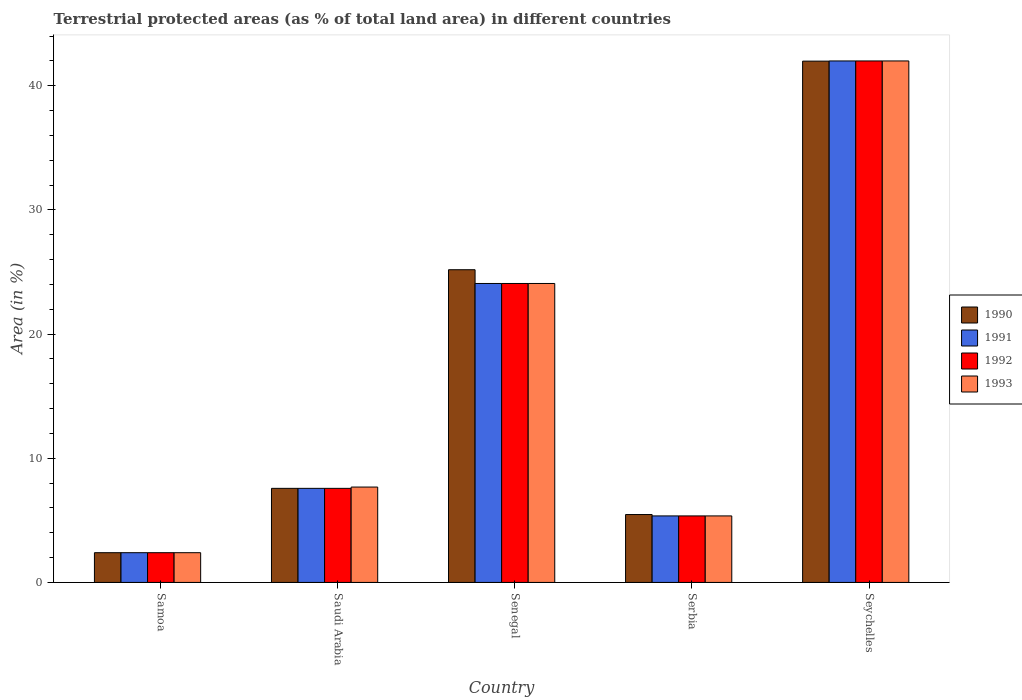How many groups of bars are there?
Your response must be concise. 5. What is the label of the 4th group of bars from the left?
Provide a short and direct response. Serbia. What is the percentage of terrestrial protected land in 1990 in Senegal?
Offer a terse response. 25.18. Across all countries, what is the maximum percentage of terrestrial protected land in 1993?
Provide a succinct answer. 41.99. Across all countries, what is the minimum percentage of terrestrial protected land in 1993?
Offer a terse response. 2.4. In which country was the percentage of terrestrial protected land in 1990 maximum?
Ensure brevity in your answer.  Seychelles. In which country was the percentage of terrestrial protected land in 1990 minimum?
Make the answer very short. Samoa. What is the total percentage of terrestrial protected land in 1992 in the graph?
Provide a short and direct response. 81.39. What is the difference between the percentage of terrestrial protected land in 1991 in Saudi Arabia and that in Seychelles?
Offer a terse response. -34.42. What is the difference between the percentage of terrestrial protected land in 1993 in Saudi Arabia and the percentage of terrestrial protected land in 1992 in Serbia?
Your answer should be very brief. 2.32. What is the average percentage of terrestrial protected land in 1992 per country?
Ensure brevity in your answer.  16.28. What is the difference between the percentage of terrestrial protected land of/in 1993 and percentage of terrestrial protected land of/in 1990 in Serbia?
Your answer should be compact. -0.11. What is the ratio of the percentage of terrestrial protected land in 1992 in Saudi Arabia to that in Senegal?
Provide a short and direct response. 0.31. Is the difference between the percentage of terrestrial protected land in 1993 in Samoa and Seychelles greater than the difference between the percentage of terrestrial protected land in 1990 in Samoa and Seychelles?
Provide a short and direct response. No. What is the difference between the highest and the second highest percentage of terrestrial protected land in 1990?
Make the answer very short. 16.8. What is the difference between the highest and the lowest percentage of terrestrial protected land in 1992?
Provide a short and direct response. 39.6. What does the 1st bar from the left in Senegal represents?
Ensure brevity in your answer.  1990. What does the 4th bar from the right in Senegal represents?
Offer a terse response. 1990. Is it the case that in every country, the sum of the percentage of terrestrial protected land in 1992 and percentage of terrestrial protected land in 1993 is greater than the percentage of terrestrial protected land in 1991?
Offer a very short reply. Yes. Does the graph contain grids?
Offer a very short reply. No. How many legend labels are there?
Offer a terse response. 4. How are the legend labels stacked?
Keep it short and to the point. Vertical. What is the title of the graph?
Give a very brief answer. Terrestrial protected areas (as % of total land area) in different countries. What is the label or title of the Y-axis?
Make the answer very short. Area (in %). What is the Area (in %) of 1990 in Samoa?
Keep it short and to the point. 2.4. What is the Area (in %) in 1991 in Samoa?
Ensure brevity in your answer.  2.4. What is the Area (in %) of 1992 in Samoa?
Your response must be concise. 2.4. What is the Area (in %) in 1993 in Samoa?
Offer a very short reply. 2.4. What is the Area (in %) of 1990 in Saudi Arabia?
Make the answer very short. 7.58. What is the Area (in %) of 1991 in Saudi Arabia?
Ensure brevity in your answer.  7.58. What is the Area (in %) of 1992 in Saudi Arabia?
Your answer should be very brief. 7.58. What is the Area (in %) of 1993 in Saudi Arabia?
Your response must be concise. 7.68. What is the Area (in %) in 1990 in Senegal?
Offer a very short reply. 25.18. What is the Area (in %) of 1991 in Senegal?
Ensure brevity in your answer.  24.07. What is the Area (in %) in 1992 in Senegal?
Ensure brevity in your answer.  24.07. What is the Area (in %) in 1993 in Senegal?
Your response must be concise. 24.07. What is the Area (in %) of 1990 in Serbia?
Your answer should be compact. 5.47. What is the Area (in %) of 1991 in Serbia?
Your answer should be very brief. 5.36. What is the Area (in %) of 1992 in Serbia?
Give a very brief answer. 5.36. What is the Area (in %) of 1993 in Serbia?
Your response must be concise. 5.36. What is the Area (in %) in 1990 in Seychelles?
Give a very brief answer. 41.98. What is the Area (in %) of 1991 in Seychelles?
Offer a very short reply. 41.99. What is the Area (in %) of 1992 in Seychelles?
Give a very brief answer. 41.99. What is the Area (in %) of 1993 in Seychelles?
Make the answer very short. 41.99. Across all countries, what is the maximum Area (in %) in 1990?
Ensure brevity in your answer.  41.98. Across all countries, what is the maximum Area (in %) in 1991?
Provide a short and direct response. 41.99. Across all countries, what is the maximum Area (in %) of 1992?
Your response must be concise. 41.99. Across all countries, what is the maximum Area (in %) of 1993?
Your response must be concise. 41.99. Across all countries, what is the minimum Area (in %) in 1990?
Offer a terse response. 2.4. Across all countries, what is the minimum Area (in %) in 1991?
Provide a short and direct response. 2.4. Across all countries, what is the minimum Area (in %) of 1992?
Offer a terse response. 2.4. Across all countries, what is the minimum Area (in %) in 1993?
Your answer should be compact. 2.4. What is the total Area (in %) in 1990 in the graph?
Ensure brevity in your answer.  82.6. What is the total Area (in %) of 1991 in the graph?
Offer a terse response. 81.39. What is the total Area (in %) in 1992 in the graph?
Give a very brief answer. 81.39. What is the total Area (in %) in 1993 in the graph?
Your response must be concise. 81.5. What is the difference between the Area (in %) in 1990 in Samoa and that in Saudi Arabia?
Offer a very short reply. -5.18. What is the difference between the Area (in %) in 1991 in Samoa and that in Saudi Arabia?
Provide a succinct answer. -5.18. What is the difference between the Area (in %) in 1992 in Samoa and that in Saudi Arabia?
Your answer should be compact. -5.18. What is the difference between the Area (in %) of 1993 in Samoa and that in Saudi Arabia?
Your response must be concise. -5.29. What is the difference between the Area (in %) in 1990 in Samoa and that in Senegal?
Offer a terse response. -22.79. What is the difference between the Area (in %) of 1991 in Samoa and that in Senegal?
Give a very brief answer. -21.68. What is the difference between the Area (in %) in 1992 in Samoa and that in Senegal?
Provide a short and direct response. -21.68. What is the difference between the Area (in %) of 1993 in Samoa and that in Senegal?
Make the answer very short. -21.68. What is the difference between the Area (in %) of 1990 in Samoa and that in Serbia?
Provide a short and direct response. -3.07. What is the difference between the Area (in %) in 1991 in Samoa and that in Serbia?
Give a very brief answer. -2.96. What is the difference between the Area (in %) in 1992 in Samoa and that in Serbia?
Your answer should be very brief. -2.96. What is the difference between the Area (in %) in 1993 in Samoa and that in Serbia?
Your answer should be compact. -2.96. What is the difference between the Area (in %) of 1990 in Samoa and that in Seychelles?
Make the answer very short. -39.58. What is the difference between the Area (in %) in 1991 in Samoa and that in Seychelles?
Your answer should be compact. -39.6. What is the difference between the Area (in %) of 1992 in Samoa and that in Seychelles?
Keep it short and to the point. -39.6. What is the difference between the Area (in %) of 1993 in Samoa and that in Seychelles?
Provide a short and direct response. -39.6. What is the difference between the Area (in %) in 1990 in Saudi Arabia and that in Senegal?
Offer a very short reply. -17.6. What is the difference between the Area (in %) of 1991 in Saudi Arabia and that in Senegal?
Give a very brief answer. -16.5. What is the difference between the Area (in %) of 1992 in Saudi Arabia and that in Senegal?
Make the answer very short. -16.5. What is the difference between the Area (in %) of 1993 in Saudi Arabia and that in Senegal?
Ensure brevity in your answer.  -16.39. What is the difference between the Area (in %) of 1990 in Saudi Arabia and that in Serbia?
Ensure brevity in your answer.  2.11. What is the difference between the Area (in %) in 1991 in Saudi Arabia and that in Serbia?
Your response must be concise. 2.22. What is the difference between the Area (in %) of 1992 in Saudi Arabia and that in Serbia?
Offer a terse response. 2.22. What is the difference between the Area (in %) of 1993 in Saudi Arabia and that in Serbia?
Give a very brief answer. 2.32. What is the difference between the Area (in %) of 1990 in Saudi Arabia and that in Seychelles?
Your answer should be very brief. -34.4. What is the difference between the Area (in %) of 1991 in Saudi Arabia and that in Seychelles?
Make the answer very short. -34.42. What is the difference between the Area (in %) of 1992 in Saudi Arabia and that in Seychelles?
Make the answer very short. -34.42. What is the difference between the Area (in %) of 1993 in Saudi Arabia and that in Seychelles?
Offer a very short reply. -34.31. What is the difference between the Area (in %) in 1990 in Senegal and that in Serbia?
Give a very brief answer. 19.71. What is the difference between the Area (in %) in 1991 in Senegal and that in Serbia?
Provide a short and direct response. 18.72. What is the difference between the Area (in %) in 1992 in Senegal and that in Serbia?
Give a very brief answer. 18.72. What is the difference between the Area (in %) in 1993 in Senegal and that in Serbia?
Your response must be concise. 18.72. What is the difference between the Area (in %) of 1990 in Senegal and that in Seychelles?
Give a very brief answer. -16.8. What is the difference between the Area (in %) in 1991 in Senegal and that in Seychelles?
Offer a very short reply. -17.92. What is the difference between the Area (in %) of 1992 in Senegal and that in Seychelles?
Give a very brief answer. -17.92. What is the difference between the Area (in %) in 1993 in Senegal and that in Seychelles?
Offer a terse response. -17.92. What is the difference between the Area (in %) of 1990 in Serbia and that in Seychelles?
Provide a succinct answer. -36.51. What is the difference between the Area (in %) in 1991 in Serbia and that in Seychelles?
Make the answer very short. -36.64. What is the difference between the Area (in %) of 1992 in Serbia and that in Seychelles?
Your answer should be very brief. -36.64. What is the difference between the Area (in %) in 1993 in Serbia and that in Seychelles?
Provide a short and direct response. -36.64. What is the difference between the Area (in %) of 1990 in Samoa and the Area (in %) of 1991 in Saudi Arabia?
Keep it short and to the point. -5.18. What is the difference between the Area (in %) in 1990 in Samoa and the Area (in %) in 1992 in Saudi Arabia?
Ensure brevity in your answer.  -5.18. What is the difference between the Area (in %) of 1990 in Samoa and the Area (in %) of 1993 in Saudi Arabia?
Offer a terse response. -5.29. What is the difference between the Area (in %) in 1991 in Samoa and the Area (in %) in 1992 in Saudi Arabia?
Ensure brevity in your answer.  -5.18. What is the difference between the Area (in %) of 1991 in Samoa and the Area (in %) of 1993 in Saudi Arabia?
Provide a short and direct response. -5.29. What is the difference between the Area (in %) in 1992 in Samoa and the Area (in %) in 1993 in Saudi Arabia?
Provide a short and direct response. -5.29. What is the difference between the Area (in %) in 1990 in Samoa and the Area (in %) in 1991 in Senegal?
Keep it short and to the point. -21.68. What is the difference between the Area (in %) in 1990 in Samoa and the Area (in %) in 1992 in Senegal?
Your answer should be compact. -21.68. What is the difference between the Area (in %) in 1990 in Samoa and the Area (in %) in 1993 in Senegal?
Ensure brevity in your answer.  -21.68. What is the difference between the Area (in %) in 1991 in Samoa and the Area (in %) in 1992 in Senegal?
Provide a succinct answer. -21.68. What is the difference between the Area (in %) in 1991 in Samoa and the Area (in %) in 1993 in Senegal?
Your answer should be very brief. -21.68. What is the difference between the Area (in %) of 1992 in Samoa and the Area (in %) of 1993 in Senegal?
Give a very brief answer. -21.68. What is the difference between the Area (in %) in 1990 in Samoa and the Area (in %) in 1991 in Serbia?
Provide a succinct answer. -2.96. What is the difference between the Area (in %) of 1990 in Samoa and the Area (in %) of 1992 in Serbia?
Give a very brief answer. -2.96. What is the difference between the Area (in %) in 1990 in Samoa and the Area (in %) in 1993 in Serbia?
Offer a terse response. -2.96. What is the difference between the Area (in %) of 1991 in Samoa and the Area (in %) of 1992 in Serbia?
Make the answer very short. -2.96. What is the difference between the Area (in %) in 1991 in Samoa and the Area (in %) in 1993 in Serbia?
Offer a very short reply. -2.96. What is the difference between the Area (in %) in 1992 in Samoa and the Area (in %) in 1993 in Serbia?
Provide a succinct answer. -2.96. What is the difference between the Area (in %) of 1990 in Samoa and the Area (in %) of 1991 in Seychelles?
Provide a short and direct response. -39.6. What is the difference between the Area (in %) of 1990 in Samoa and the Area (in %) of 1992 in Seychelles?
Keep it short and to the point. -39.6. What is the difference between the Area (in %) of 1990 in Samoa and the Area (in %) of 1993 in Seychelles?
Your response must be concise. -39.6. What is the difference between the Area (in %) of 1991 in Samoa and the Area (in %) of 1992 in Seychelles?
Provide a succinct answer. -39.6. What is the difference between the Area (in %) in 1991 in Samoa and the Area (in %) in 1993 in Seychelles?
Ensure brevity in your answer.  -39.6. What is the difference between the Area (in %) of 1992 in Samoa and the Area (in %) of 1993 in Seychelles?
Give a very brief answer. -39.6. What is the difference between the Area (in %) in 1990 in Saudi Arabia and the Area (in %) in 1991 in Senegal?
Provide a short and direct response. -16.5. What is the difference between the Area (in %) in 1990 in Saudi Arabia and the Area (in %) in 1992 in Senegal?
Offer a terse response. -16.5. What is the difference between the Area (in %) of 1990 in Saudi Arabia and the Area (in %) of 1993 in Senegal?
Ensure brevity in your answer.  -16.5. What is the difference between the Area (in %) of 1991 in Saudi Arabia and the Area (in %) of 1992 in Senegal?
Provide a short and direct response. -16.5. What is the difference between the Area (in %) in 1991 in Saudi Arabia and the Area (in %) in 1993 in Senegal?
Make the answer very short. -16.5. What is the difference between the Area (in %) of 1992 in Saudi Arabia and the Area (in %) of 1993 in Senegal?
Provide a succinct answer. -16.5. What is the difference between the Area (in %) in 1990 in Saudi Arabia and the Area (in %) in 1991 in Serbia?
Your answer should be compact. 2.22. What is the difference between the Area (in %) in 1990 in Saudi Arabia and the Area (in %) in 1992 in Serbia?
Make the answer very short. 2.22. What is the difference between the Area (in %) in 1990 in Saudi Arabia and the Area (in %) in 1993 in Serbia?
Your response must be concise. 2.22. What is the difference between the Area (in %) of 1991 in Saudi Arabia and the Area (in %) of 1992 in Serbia?
Keep it short and to the point. 2.22. What is the difference between the Area (in %) in 1991 in Saudi Arabia and the Area (in %) in 1993 in Serbia?
Provide a succinct answer. 2.22. What is the difference between the Area (in %) of 1992 in Saudi Arabia and the Area (in %) of 1993 in Serbia?
Keep it short and to the point. 2.22. What is the difference between the Area (in %) of 1990 in Saudi Arabia and the Area (in %) of 1991 in Seychelles?
Provide a short and direct response. -34.42. What is the difference between the Area (in %) of 1990 in Saudi Arabia and the Area (in %) of 1992 in Seychelles?
Keep it short and to the point. -34.42. What is the difference between the Area (in %) of 1990 in Saudi Arabia and the Area (in %) of 1993 in Seychelles?
Offer a very short reply. -34.42. What is the difference between the Area (in %) of 1991 in Saudi Arabia and the Area (in %) of 1992 in Seychelles?
Offer a terse response. -34.42. What is the difference between the Area (in %) in 1991 in Saudi Arabia and the Area (in %) in 1993 in Seychelles?
Your answer should be compact. -34.42. What is the difference between the Area (in %) in 1992 in Saudi Arabia and the Area (in %) in 1993 in Seychelles?
Give a very brief answer. -34.42. What is the difference between the Area (in %) in 1990 in Senegal and the Area (in %) in 1991 in Serbia?
Offer a very short reply. 19.82. What is the difference between the Area (in %) of 1990 in Senegal and the Area (in %) of 1992 in Serbia?
Provide a succinct answer. 19.82. What is the difference between the Area (in %) in 1990 in Senegal and the Area (in %) in 1993 in Serbia?
Make the answer very short. 19.82. What is the difference between the Area (in %) in 1991 in Senegal and the Area (in %) in 1992 in Serbia?
Give a very brief answer. 18.72. What is the difference between the Area (in %) in 1991 in Senegal and the Area (in %) in 1993 in Serbia?
Give a very brief answer. 18.72. What is the difference between the Area (in %) of 1992 in Senegal and the Area (in %) of 1993 in Serbia?
Provide a short and direct response. 18.72. What is the difference between the Area (in %) in 1990 in Senegal and the Area (in %) in 1991 in Seychelles?
Your response must be concise. -16.81. What is the difference between the Area (in %) in 1990 in Senegal and the Area (in %) in 1992 in Seychelles?
Ensure brevity in your answer.  -16.81. What is the difference between the Area (in %) of 1990 in Senegal and the Area (in %) of 1993 in Seychelles?
Keep it short and to the point. -16.81. What is the difference between the Area (in %) in 1991 in Senegal and the Area (in %) in 1992 in Seychelles?
Your response must be concise. -17.92. What is the difference between the Area (in %) in 1991 in Senegal and the Area (in %) in 1993 in Seychelles?
Your answer should be very brief. -17.92. What is the difference between the Area (in %) of 1992 in Senegal and the Area (in %) of 1993 in Seychelles?
Your answer should be compact. -17.92. What is the difference between the Area (in %) of 1990 in Serbia and the Area (in %) of 1991 in Seychelles?
Provide a succinct answer. -36.52. What is the difference between the Area (in %) in 1990 in Serbia and the Area (in %) in 1992 in Seychelles?
Provide a succinct answer. -36.52. What is the difference between the Area (in %) of 1990 in Serbia and the Area (in %) of 1993 in Seychelles?
Provide a short and direct response. -36.52. What is the difference between the Area (in %) of 1991 in Serbia and the Area (in %) of 1992 in Seychelles?
Provide a succinct answer. -36.64. What is the difference between the Area (in %) of 1991 in Serbia and the Area (in %) of 1993 in Seychelles?
Provide a succinct answer. -36.64. What is the difference between the Area (in %) of 1992 in Serbia and the Area (in %) of 1993 in Seychelles?
Keep it short and to the point. -36.64. What is the average Area (in %) in 1990 per country?
Your response must be concise. 16.52. What is the average Area (in %) of 1991 per country?
Make the answer very short. 16.28. What is the average Area (in %) in 1992 per country?
Offer a very short reply. 16.28. What is the average Area (in %) in 1993 per country?
Your response must be concise. 16.3. What is the difference between the Area (in %) of 1990 and Area (in %) of 1991 in Samoa?
Provide a succinct answer. 0. What is the difference between the Area (in %) in 1990 and Area (in %) in 1993 in Samoa?
Offer a very short reply. 0. What is the difference between the Area (in %) of 1991 and Area (in %) of 1993 in Samoa?
Ensure brevity in your answer.  0. What is the difference between the Area (in %) in 1992 and Area (in %) in 1993 in Samoa?
Your answer should be compact. 0. What is the difference between the Area (in %) of 1990 and Area (in %) of 1993 in Saudi Arabia?
Provide a succinct answer. -0.11. What is the difference between the Area (in %) in 1991 and Area (in %) in 1993 in Saudi Arabia?
Ensure brevity in your answer.  -0.11. What is the difference between the Area (in %) in 1992 and Area (in %) in 1993 in Saudi Arabia?
Your response must be concise. -0.11. What is the difference between the Area (in %) of 1990 and Area (in %) of 1991 in Senegal?
Offer a terse response. 1.11. What is the difference between the Area (in %) of 1990 and Area (in %) of 1992 in Senegal?
Give a very brief answer. 1.11. What is the difference between the Area (in %) in 1990 and Area (in %) in 1993 in Senegal?
Make the answer very short. 1.11. What is the difference between the Area (in %) in 1991 and Area (in %) in 1993 in Senegal?
Ensure brevity in your answer.  0. What is the difference between the Area (in %) in 1992 and Area (in %) in 1993 in Senegal?
Your answer should be very brief. 0. What is the difference between the Area (in %) of 1990 and Area (in %) of 1991 in Serbia?
Your answer should be compact. 0.11. What is the difference between the Area (in %) of 1990 and Area (in %) of 1992 in Serbia?
Your answer should be compact. 0.11. What is the difference between the Area (in %) of 1990 and Area (in %) of 1993 in Serbia?
Your answer should be compact. 0.11. What is the difference between the Area (in %) of 1992 and Area (in %) of 1993 in Serbia?
Your response must be concise. 0. What is the difference between the Area (in %) of 1990 and Area (in %) of 1991 in Seychelles?
Keep it short and to the point. -0.01. What is the difference between the Area (in %) in 1990 and Area (in %) in 1992 in Seychelles?
Offer a terse response. -0.01. What is the difference between the Area (in %) of 1990 and Area (in %) of 1993 in Seychelles?
Your answer should be very brief. -0.01. What is the difference between the Area (in %) in 1991 and Area (in %) in 1992 in Seychelles?
Offer a terse response. 0. What is the difference between the Area (in %) in 1991 and Area (in %) in 1993 in Seychelles?
Provide a succinct answer. 0. What is the ratio of the Area (in %) of 1990 in Samoa to that in Saudi Arabia?
Provide a succinct answer. 0.32. What is the ratio of the Area (in %) of 1991 in Samoa to that in Saudi Arabia?
Ensure brevity in your answer.  0.32. What is the ratio of the Area (in %) in 1992 in Samoa to that in Saudi Arabia?
Your answer should be compact. 0.32. What is the ratio of the Area (in %) of 1993 in Samoa to that in Saudi Arabia?
Provide a succinct answer. 0.31. What is the ratio of the Area (in %) in 1990 in Samoa to that in Senegal?
Provide a succinct answer. 0.1. What is the ratio of the Area (in %) in 1991 in Samoa to that in Senegal?
Keep it short and to the point. 0.1. What is the ratio of the Area (in %) in 1992 in Samoa to that in Senegal?
Keep it short and to the point. 0.1. What is the ratio of the Area (in %) in 1993 in Samoa to that in Senegal?
Your response must be concise. 0.1. What is the ratio of the Area (in %) of 1990 in Samoa to that in Serbia?
Offer a very short reply. 0.44. What is the ratio of the Area (in %) in 1991 in Samoa to that in Serbia?
Ensure brevity in your answer.  0.45. What is the ratio of the Area (in %) of 1992 in Samoa to that in Serbia?
Keep it short and to the point. 0.45. What is the ratio of the Area (in %) in 1993 in Samoa to that in Serbia?
Offer a very short reply. 0.45. What is the ratio of the Area (in %) in 1990 in Samoa to that in Seychelles?
Ensure brevity in your answer.  0.06. What is the ratio of the Area (in %) in 1991 in Samoa to that in Seychelles?
Offer a terse response. 0.06. What is the ratio of the Area (in %) of 1992 in Samoa to that in Seychelles?
Offer a terse response. 0.06. What is the ratio of the Area (in %) in 1993 in Samoa to that in Seychelles?
Your response must be concise. 0.06. What is the ratio of the Area (in %) in 1990 in Saudi Arabia to that in Senegal?
Offer a terse response. 0.3. What is the ratio of the Area (in %) in 1991 in Saudi Arabia to that in Senegal?
Provide a short and direct response. 0.31. What is the ratio of the Area (in %) in 1992 in Saudi Arabia to that in Senegal?
Keep it short and to the point. 0.31. What is the ratio of the Area (in %) in 1993 in Saudi Arabia to that in Senegal?
Offer a terse response. 0.32. What is the ratio of the Area (in %) in 1990 in Saudi Arabia to that in Serbia?
Your answer should be very brief. 1.39. What is the ratio of the Area (in %) in 1991 in Saudi Arabia to that in Serbia?
Keep it short and to the point. 1.41. What is the ratio of the Area (in %) in 1992 in Saudi Arabia to that in Serbia?
Provide a succinct answer. 1.41. What is the ratio of the Area (in %) in 1993 in Saudi Arabia to that in Serbia?
Make the answer very short. 1.43. What is the ratio of the Area (in %) in 1990 in Saudi Arabia to that in Seychelles?
Make the answer very short. 0.18. What is the ratio of the Area (in %) of 1991 in Saudi Arabia to that in Seychelles?
Offer a very short reply. 0.18. What is the ratio of the Area (in %) in 1992 in Saudi Arabia to that in Seychelles?
Your answer should be very brief. 0.18. What is the ratio of the Area (in %) of 1993 in Saudi Arabia to that in Seychelles?
Your answer should be very brief. 0.18. What is the ratio of the Area (in %) of 1990 in Senegal to that in Serbia?
Give a very brief answer. 4.61. What is the ratio of the Area (in %) of 1991 in Senegal to that in Serbia?
Keep it short and to the point. 4.49. What is the ratio of the Area (in %) of 1992 in Senegal to that in Serbia?
Make the answer very short. 4.49. What is the ratio of the Area (in %) in 1993 in Senegal to that in Serbia?
Your answer should be compact. 4.49. What is the ratio of the Area (in %) of 1990 in Senegal to that in Seychelles?
Make the answer very short. 0.6. What is the ratio of the Area (in %) of 1991 in Senegal to that in Seychelles?
Offer a terse response. 0.57. What is the ratio of the Area (in %) of 1992 in Senegal to that in Seychelles?
Offer a terse response. 0.57. What is the ratio of the Area (in %) in 1993 in Senegal to that in Seychelles?
Keep it short and to the point. 0.57. What is the ratio of the Area (in %) in 1990 in Serbia to that in Seychelles?
Your answer should be very brief. 0.13. What is the ratio of the Area (in %) in 1991 in Serbia to that in Seychelles?
Offer a very short reply. 0.13. What is the ratio of the Area (in %) in 1992 in Serbia to that in Seychelles?
Your answer should be compact. 0.13. What is the ratio of the Area (in %) in 1993 in Serbia to that in Seychelles?
Your answer should be compact. 0.13. What is the difference between the highest and the second highest Area (in %) of 1990?
Your answer should be very brief. 16.8. What is the difference between the highest and the second highest Area (in %) of 1991?
Your answer should be very brief. 17.92. What is the difference between the highest and the second highest Area (in %) in 1992?
Give a very brief answer. 17.92. What is the difference between the highest and the second highest Area (in %) of 1993?
Offer a very short reply. 17.92. What is the difference between the highest and the lowest Area (in %) in 1990?
Provide a short and direct response. 39.58. What is the difference between the highest and the lowest Area (in %) in 1991?
Provide a short and direct response. 39.6. What is the difference between the highest and the lowest Area (in %) in 1992?
Make the answer very short. 39.6. What is the difference between the highest and the lowest Area (in %) in 1993?
Keep it short and to the point. 39.6. 